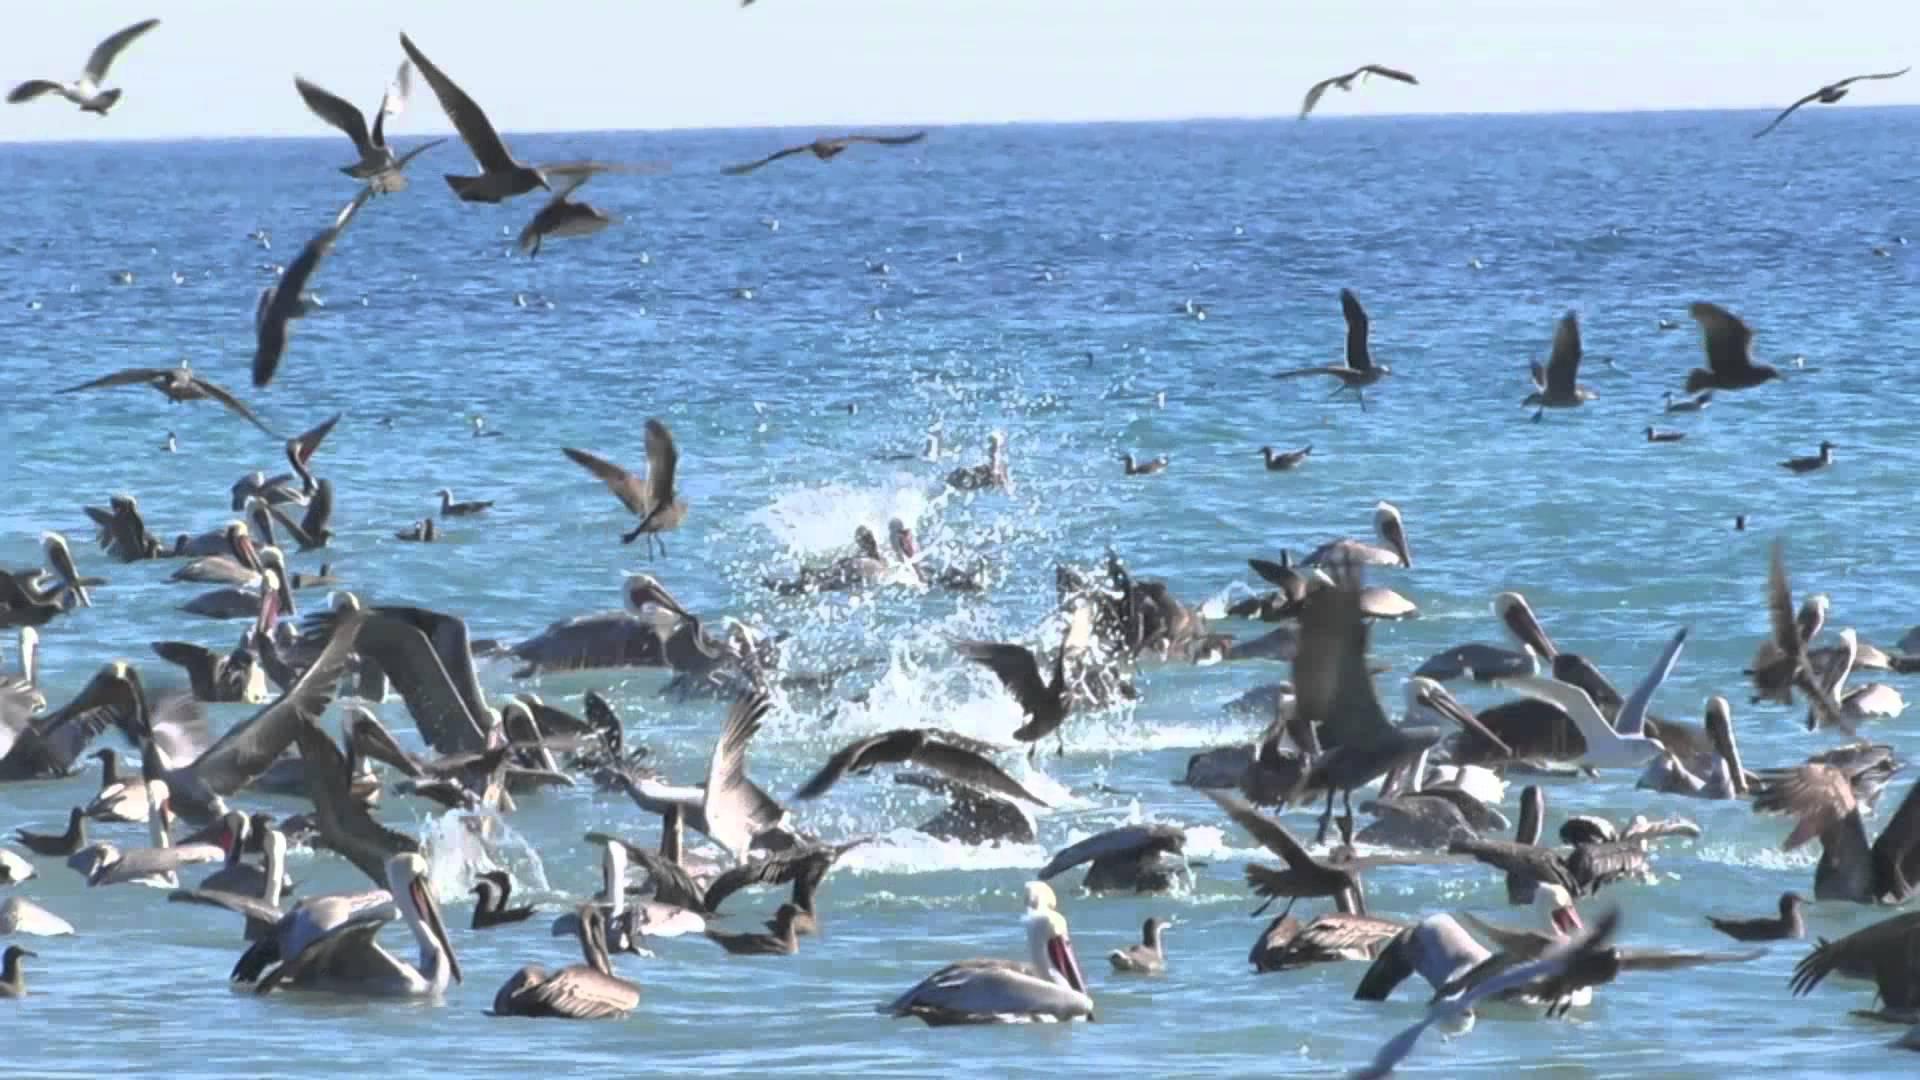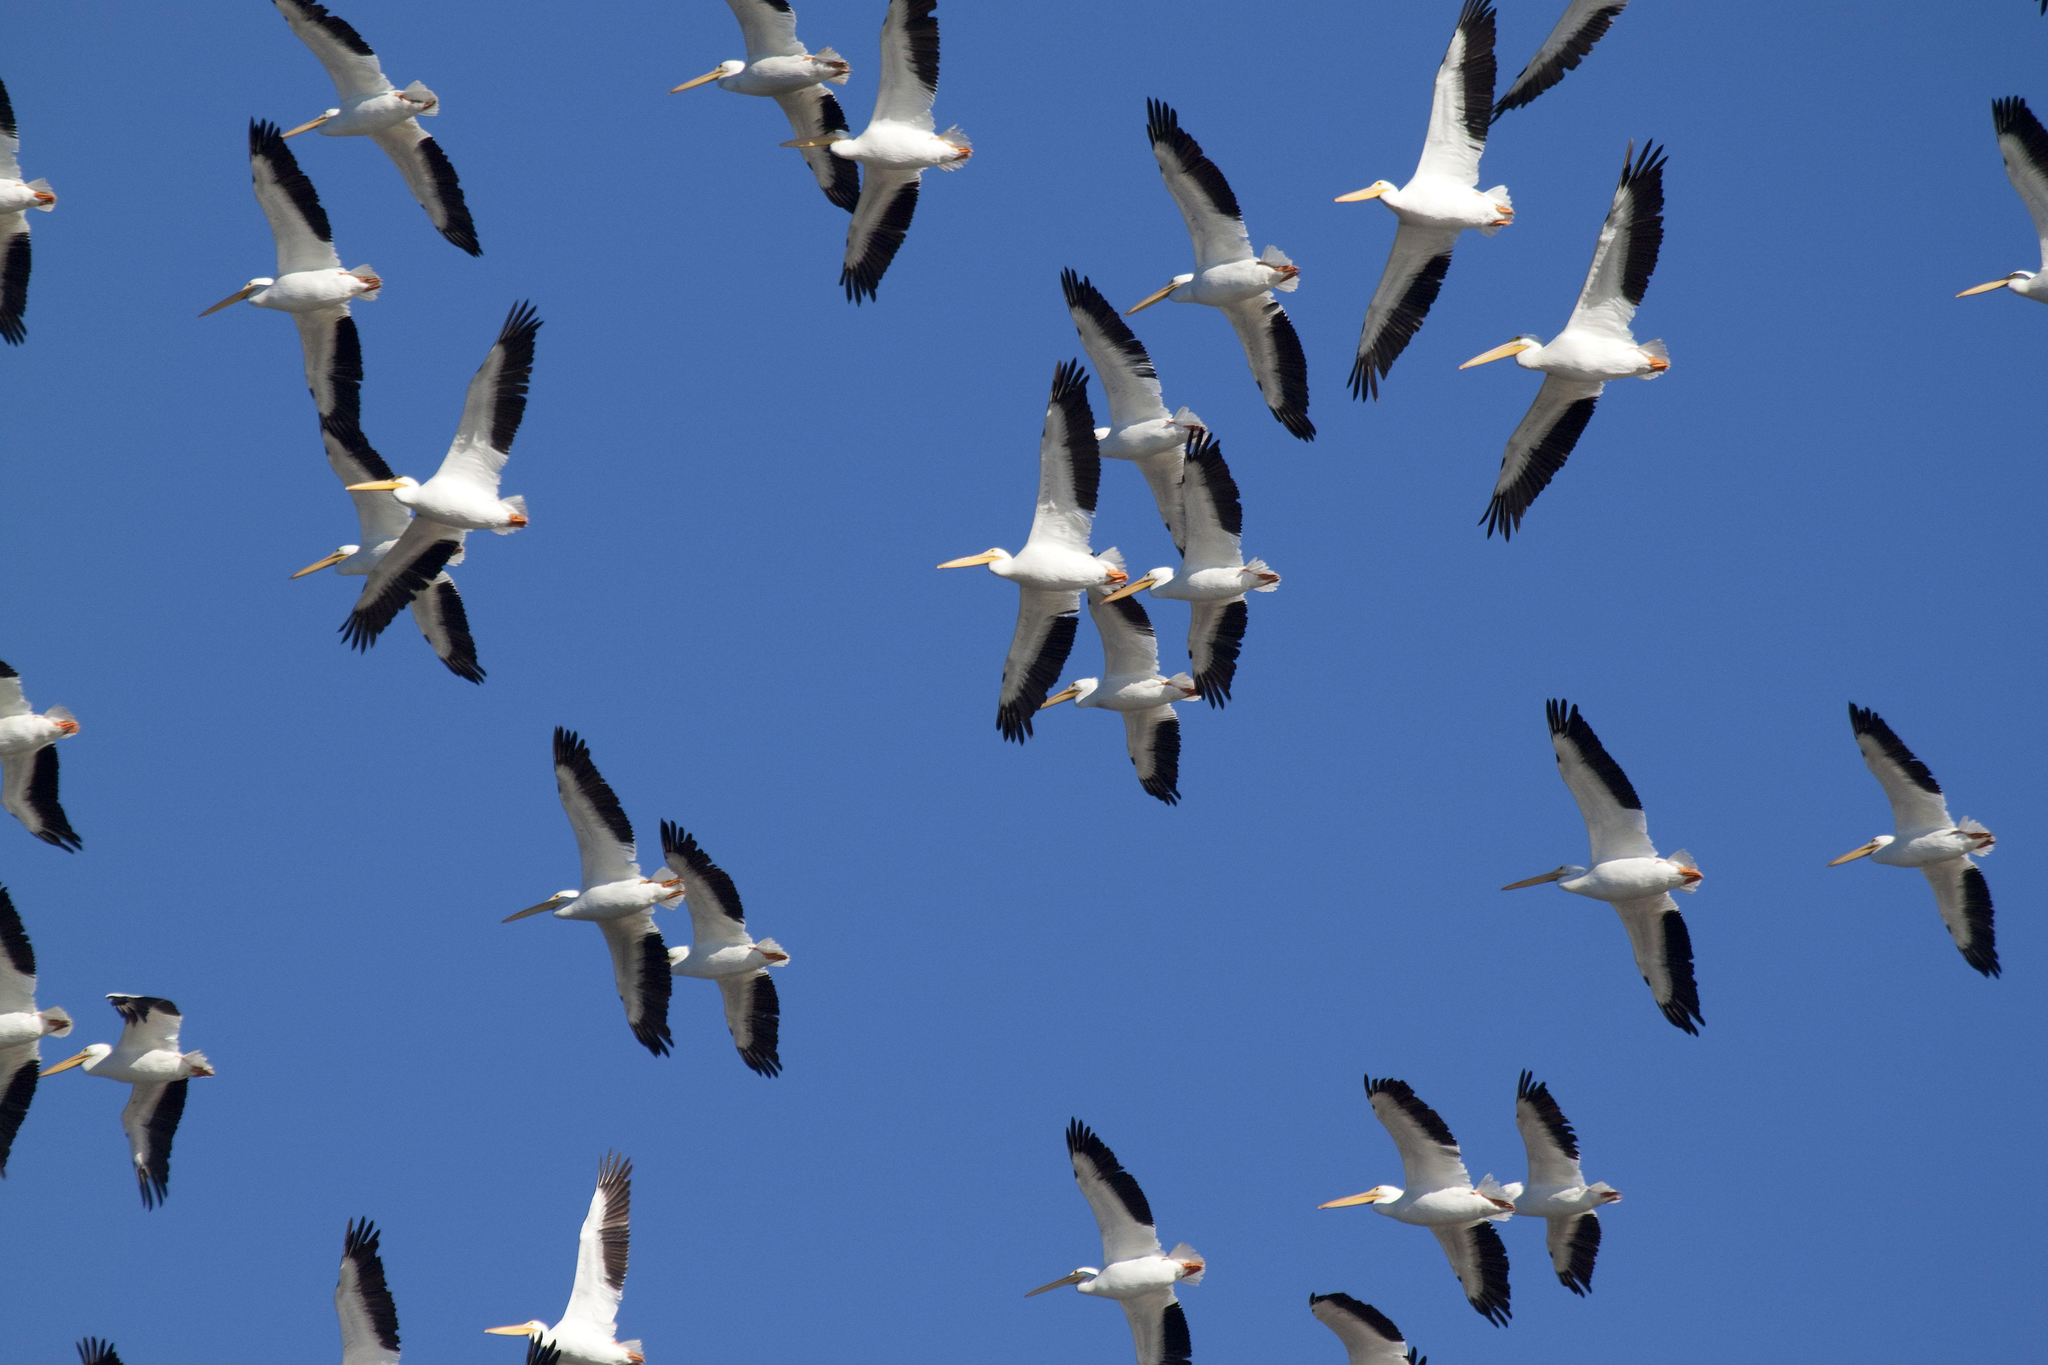The first image is the image on the left, the second image is the image on the right. Given the left and right images, does the statement "In one image there are some birds above the water." hold true? Answer yes or no. Yes. 